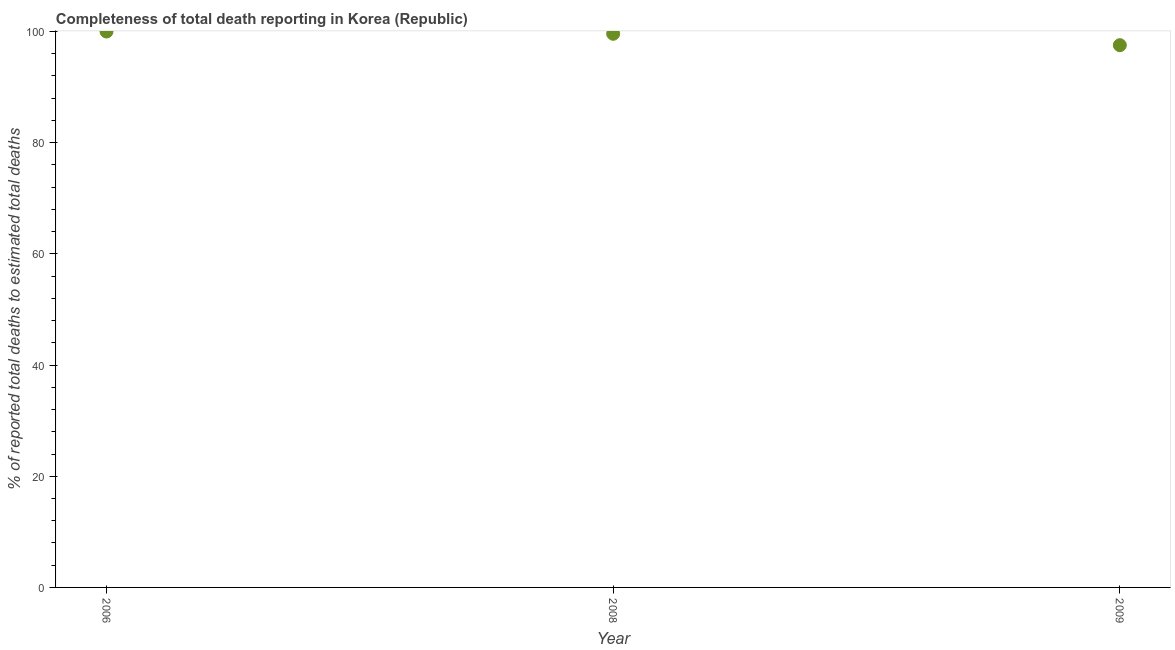What is the completeness of total death reports in 2006?
Keep it short and to the point. 100. Across all years, what is the maximum completeness of total death reports?
Your response must be concise. 100. Across all years, what is the minimum completeness of total death reports?
Offer a terse response. 97.54. In which year was the completeness of total death reports maximum?
Give a very brief answer. 2006. What is the sum of the completeness of total death reports?
Your response must be concise. 297.13. What is the difference between the completeness of total death reports in 2006 and 2009?
Provide a short and direct response. 2.46. What is the average completeness of total death reports per year?
Your answer should be compact. 99.04. What is the median completeness of total death reports?
Provide a short and direct response. 99.59. In how many years, is the completeness of total death reports greater than 20 %?
Ensure brevity in your answer.  3. Do a majority of the years between 2006 and 2008 (inclusive) have completeness of total death reports greater than 88 %?
Provide a succinct answer. Yes. What is the ratio of the completeness of total death reports in 2006 to that in 2009?
Your answer should be very brief. 1.03. Is the completeness of total death reports in 2008 less than that in 2009?
Provide a succinct answer. No. Is the difference between the completeness of total death reports in 2006 and 2009 greater than the difference between any two years?
Your answer should be very brief. Yes. What is the difference between the highest and the second highest completeness of total death reports?
Make the answer very short. 0.41. Is the sum of the completeness of total death reports in 2008 and 2009 greater than the maximum completeness of total death reports across all years?
Your answer should be compact. Yes. What is the difference between the highest and the lowest completeness of total death reports?
Keep it short and to the point. 2.46. How many dotlines are there?
Offer a terse response. 1. What is the difference between two consecutive major ticks on the Y-axis?
Offer a very short reply. 20. Does the graph contain any zero values?
Offer a very short reply. No. Does the graph contain grids?
Offer a very short reply. No. What is the title of the graph?
Give a very brief answer. Completeness of total death reporting in Korea (Republic). What is the label or title of the Y-axis?
Provide a succinct answer. % of reported total deaths to estimated total deaths. What is the % of reported total deaths to estimated total deaths in 2006?
Ensure brevity in your answer.  100. What is the % of reported total deaths to estimated total deaths in 2008?
Offer a very short reply. 99.59. What is the % of reported total deaths to estimated total deaths in 2009?
Provide a succinct answer. 97.54. What is the difference between the % of reported total deaths to estimated total deaths in 2006 and 2008?
Offer a terse response. 0.41. What is the difference between the % of reported total deaths to estimated total deaths in 2006 and 2009?
Your answer should be very brief. 2.46. What is the difference between the % of reported total deaths to estimated total deaths in 2008 and 2009?
Give a very brief answer. 2.05. What is the ratio of the % of reported total deaths to estimated total deaths in 2006 to that in 2008?
Give a very brief answer. 1. What is the ratio of the % of reported total deaths to estimated total deaths in 2006 to that in 2009?
Ensure brevity in your answer.  1.02. What is the ratio of the % of reported total deaths to estimated total deaths in 2008 to that in 2009?
Ensure brevity in your answer.  1.02. 